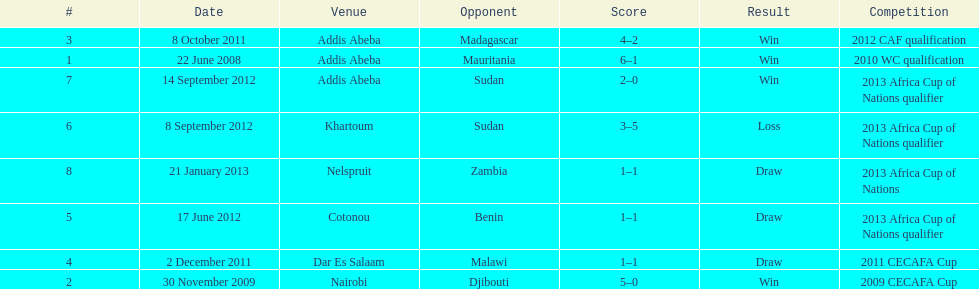How long in years down this table cover? 5. 